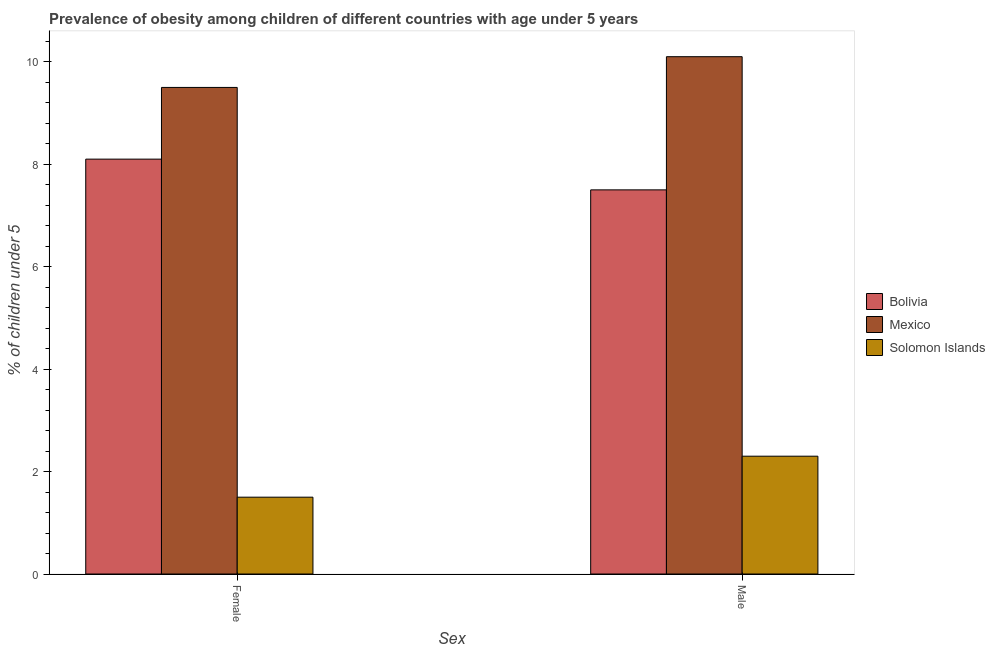How many different coloured bars are there?
Offer a very short reply. 3. Are the number of bars per tick equal to the number of legend labels?
Give a very brief answer. Yes. How many bars are there on the 1st tick from the left?
Make the answer very short. 3. Across all countries, what is the maximum percentage of obese male children?
Make the answer very short. 10.1. Across all countries, what is the minimum percentage of obese male children?
Your answer should be compact. 2.3. In which country was the percentage of obese female children maximum?
Offer a very short reply. Mexico. In which country was the percentage of obese female children minimum?
Make the answer very short. Solomon Islands. What is the total percentage of obese female children in the graph?
Provide a succinct answer. 19.1. What is the difference between the percentage of obese male children in Bolivia and that in Mexico?
Keep it short and to the point. -2.6. What is the difference between the percentage of obese male children in Solomon Islands and the percentage of obese female children in Bolivia?
Offer a terse response. -5.8. What is the average percentage of obese female children per country?
Offer a terse response. 6.37. What is the difference between the percentage of obese female children and percentage of obese male children in Solomon Islands?
Your answer should be compact. -0.8. In how many countries, is the percentage of obese female children greater than 4 %?
Your answer should be very brief. 2. What is the ratio of the percentage of obese female children in Bolivia to that in Solomon Islands?
Provide a succinct answer. 5.4. Is the percentage of obese female children in Mexico less than that in Bolivia?
Offer a terse response. No. What does the 3rd bar from the right in Female represents?
Keep it short and to the point. Bolivia. How many countries are there in the graph?
Offer a very short reply. 3. Are the values on the major ticks of Y-axis written in scientific E-notation?
Ensure brevity in your answer.  No. What is the title of the graph?
Keep it short and to the point. Prevalence of obesity among children of different countries with age under 5 years. What is the label or title of the X-axis?
Your answer should be compact. Sex. What is the label or title of the Y-axis?
Your answer should be very brief.  % of children under 5. What is the  % of children under 5 of Bolivia in Female?
Keep it short and to the point. 8.1. What is the  % of children under 5 of Solomon Islands in Female?
Provide a short and direct response. 1.5. What is the  % of children under 5 in Mexico in Male?
Ensure brevity in your answer.  10.1. What is the  % of children under 5 in Solomon Islands in Male?
Provide a succinct answer. 2.3. Across all Sex, what is the maximum  % of children under 5 of Bolivia?
Ensure brevity in your answer.  8.1. Across all Sex, what is the maximum  % of children under 5 in Mexico?
Make the answer very short. 10.1. Across all Sex, what is the maximum  % of children under 5 in Solomon Islands?
Provide a succinct answer. 2.3. Across all Sex, what is the minimum  % of children under 5 of Mexico?
Provide a succinct answer. 9.5. Across all Sex, what is the minimum  % of children under 5 in Solomon Islands?
Your response must be concise. 1.5. What is the total  % of children under 5 of Bolivia in the graph?
Your response must be concise. 15.6. What is the total  % of children under 5 in Mexico in the graph?
Make the answer very short. 19.6. What is the difference between the  % of children under 5 in Bolivia in Female and that in Male?
Offer a terse response. 0.6. What is the difference between the  % of children under 5 in Solomon Islands in Female and that in Male?
Provide a succinct answer. -0.8. What is the difference between the  % of children under 5 in Bolivia in Female and the  % of children under 5 in Solomon Islands in Male?
Your response must be concise. 5.8. What is the difference between the  % of children under 5 in Mexico in Female and the  % of children under 5 in Solomon Islands in Male?
Ensure brevity in your answer.  7.2. What is the average  % of children under 5 in Bolivia per Sex?
Keep it short and to the point. 7.8. What is the average  % of children under 5 in Solomon Islands per Sex?
Ensure brevity in your answer.  1.9. What is the difference between the  % of children under 5 in Bolivia and  % of children under 5 in Solomon Islands in Male?
Offer a terse response. 5.2. What is the ratio of the  % of children under 5 in Bolivia in Female to that in Male?
Keep it short and to the point. 1.08. What is the ratio of the  % of children under 5 of Mexico in Female to that in Male?
Provide a succinct answer. 0.94. What is the ratio of the  % of children under 5 of Solomon Islands in Female to that in Male?
Make the answer very short. 0.65. What is the difference between the highest and the second highest  % of children under 5 in Mexico?
Provide a succinct answer. 0.6. What is the difference between the highest and the lowest  % of children under 5 of Bolivia?
Your response must be concise. 0.6. What is the difference between the highest and the lowest  % of children under 5 of Mexico?
Ensure brevity in your answer.  0.6. 